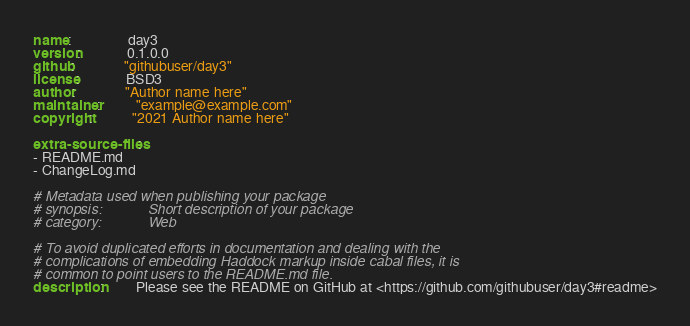Convert code to text. <code><loc_0><loc_0><loc_500><loc_500><_YAML_>name:                day3
version:             0.1.0.0
github:              "githubuser/day3"
license:             BSD3
author:              "Author name here"
maintainer:          "example@example.com"
copyright:           "2021 Author name here"

extra-source-files:
- README.md
- ChangeLog.md

# Metadata used when publishing your package
# synopsis:            Short description of your package
# category:            Web

# To avoid duplicated efforts in documentation and dealing with the
# complications of embedding Haddock markup inside cabal files, it is
# common to point users to the README.md file.
description:         Please see the README on GitHub at <https://github.com/githubuser/day3#readme>
</code> 